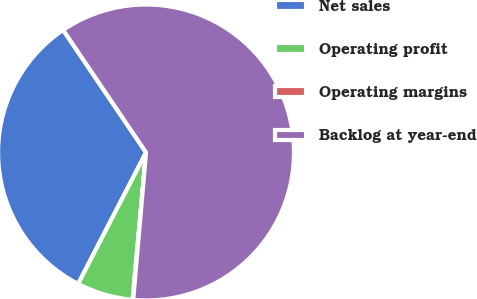Convert chart. <chart><loc_0><loc_0><loc_500><loc_500><pie_chart><fcel>Net sales<fcel>Operating profit<fcel>Operating margins<fcel>Backlog at year-end<nl><fcel>32.94%<fcel>6.14%<fcel>0.07%<fcel>60.85%<nl></chart> 